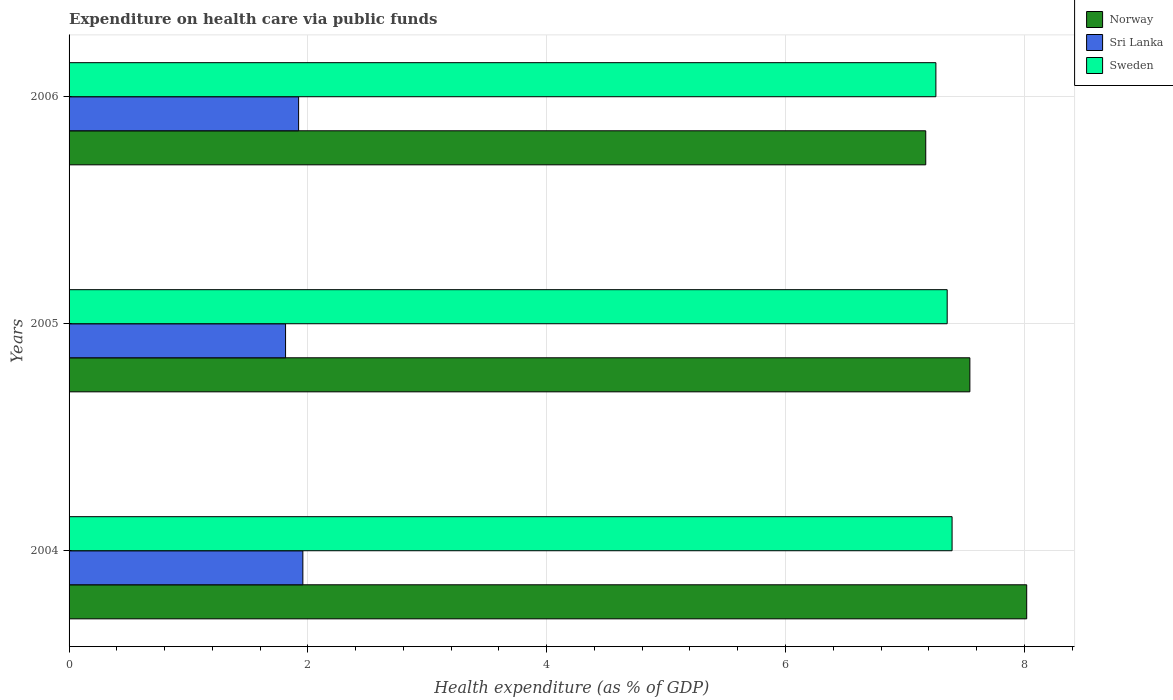Are the number of bars per tick equal to the number of legend labels?
Provide a short and direct response. Yes. Are the number of bars on each tick of the Y-axis equal?
Your answer should be very brief. Yes. How many bars are there on the 1st tick from the top?
Offer a terse response. 3. What is the expenditure made on health care in Sri Lanka in 2006?
Make the answer very short. 1.92. Across all years, what is the maximum expenditure made on health care in Sri Lanka?
Offer a terse response. 1.96. Across all years, what is the minimum expenditure made on health care in Norway?
Your response must be concise. 7.17. In which year was the expenditure made on health care in Sri Lanka maximum?
Offer a very short reply. 2004. In which year was the expenditure made on health care in Norway minimum?
Ensure brevity in your answer.  2006. What is the total expenditure made on health care in Norway in the graph?
Provide a short and direct response. 22.74. What is the difference between the expenditure made on health care in Norway in 2005 and that in 2006?
Your answer should be compact. 0.37. What is the difference between the expenditure made on health care in Sweden in 2006 and the expenditure made on health care in Norway in 2005?
Make the answer very short. -0.28. What is the average expenditure made on health care in Sweden per year?
Offer a terse response. 7.34. In the year 2004, what is the difference between the expenditure made on health care in Sweden and expenditure made on health care in Norway?
Give a very brief answer. -0.62. In how many years, is the expenditure made on health care in Norway greater than 7.2 %?
Offer a very short reply. 2. What is the ratio of the expenditure made on health care in Sweden in 2004 to that in 2005?
Provide a succinct answer. 1.01. Is the expenditure made on health care in Sri Lanka in 2005 less than that in 2006?
Your answer should be compact. Yes. What is the difference between the highest and the second highest expenditure made on health care in Sweden?
Provide a succinct answer. 0.04. What is the difference between the highest and the lowest expenditure made on health care in Sri Lanka?
Keep it short and to the point. 0.14. In how many years, is the expenditure made on health care in Norway greater than the average expenditure made on health care in Norway taken over all years?
Your response must be concise. 1. What does the 2nd bar from the top in 2004 represents?
Provide a succinct answer. Sri Lanka. What does the 3rd bar from the bottom in 2004 represents?
Offer a very short reply. Sweden. How many bars are there?
Make the answer very short. 9. How many years are there in the graph?
Give a very brief answer. 3. Does the graph contain any zero values?
Your response must be concise. No. Does the graph contain grids?
Your answer should be very brief. Yes. Where does the legend appear in the graph?
Provide a succinct answer. Top right. What is the title of the graph?
Make the answer very short. Expenditure on health care via public funds. What is the label or title of the X-axis?
Keep it short and to the point. Health expenditure (as % of GDP). What is the label or title of the Y-axis?
Your response must be concise. Years. What is the Health expenditure (as % of GDP) of Norway in 2004?
Ensure brevity in your answer.  8.02. What is the Health expenditure (as % of GDP) in Sri Lanka in 2004?
Your response must be concise. 1.96. What is the Health expenditure (as % of GDP) of Sweden in 2004?
Keep it short and to the point. 7.4. What is the Health expenditure (as % of GDP) of Norway in 2005?
Give a very brief answer. 7.54. What is the Health expenditure (as % of GDP) of Sri Lanka in 2005?
Provide a succinct answer. 1.81. What is the Health expenditure (as % of GDP) of Sweden in 2005?
Your answer should be compact. 7.35. What is the Health expenditure (as % of GDP) in Norway in 2006?
Your answer should be compact. 7.17. What is the Health expenditure (as % of GDP) in Sri Lanka in 2006?
Offer a terse response. 1.92. What is the Health expenditure (as % of GDP) in Sweden in 2006?
Keep it short and to the point. 7.26. Across all years, what is the maximum Health expenditure (as % of GDP) in Norway?
Provide a short and direct response. 8.02. Across all years, what is the maximum Health expenditure (as % of GDP) in Sri Lanka?
Offer a very short reply. 1.96. Across all years, what is the maximum Health expenditure (as % of GDP) of Sweden?
Offer a terse response. 7.4. Across all years, what is the minimum Health expenditure (as % of GDP) in Norway?
Offer a very short reply. 7.17. Across all years, what is the minimum Health expenditure (as % of GDP) of Sri Lanka?
Ensure brevity in your answer.  1.81. Across all years, what is the minimum Health expenditure (as % of GDP) of Sweden?
Provide a succinct answer. 7.26. What is the total Health expenditure (as % of GDP) of Norway in the graph?
Your answer should be very brief. 22.74. What is the total Health expenditure (as % of GDP) in Sri Lanka in the graph?
Provide a succinct answer. 5.69. What is the total Health expenditure (as % of GDP) in Sweden in the graph?
Your answer should be very brief. 22.01. What is the difference between the Health expenditure (as % of GDP) of Norway in 2004 and that in 2005?
Give a very brief answer. 0.48. What is the difference between the Health expenditure (as % of GDP) of Sri Lanka in 2004 and that in 2005?
Your response must be concise. 0.14. What is the difference between the Health expenditure (as % of GDP) in Sweden in 2004 and that in 2005?
Make the answer very short. 0.04. What is the difference between the Health expenditure (as % of GDP) of Norway in 2004 and that in 2006?
Your answer should be very brief. 0.85. What is the difference between the Health expenditure (as % of GDP) in Sri Lanka in 2004 and that in 2006?
Keep it short and to the point. 0.04. What is the difference between the Health expenditure (as % of GDP) of Sweden in 2004 and that in 2006?
Provide a succinct answer. 0.14. What is the difference between the Health expenditure (as % of GDP) of Norway in 2005 and that in 2006?
Offer a very short reply. 0.37. What is the difference between the Health expenditure (as % of GDP) in Sri Lanka in 2005 and that in 2006?
Your response must be concise. -0.11. What is the difference between the Health expenditure (as % of GDP) of Sweden in 2005 and that in 2006?
Offer a terse response. 0.09. What is the difference between the Health expenditure (as % of GDP) in Norway in 2004 and the Health expenditure (as % of GDP) in Sri Lanka in 2005?
Provide a short and direct response. 6.21. What is the difference between the Health expenditure (as % of GDP) of Norway in 2004 and the Health expenditure (as % of GDP) of Sweden in 2005?
Provide a succinct answer. 0.67. What is the difference between the Health expenditure (as % of GDP) in Sri Lanka in 2004 and the Health expenditure (as % of GDP) in Sweden in 2005?
Keep it short and to the point. -5.4. What is the difference between the Health expenditure (as % of GDP) in Norway in 2004 and the Health expenditure (as % of GDP) in Sri Lanka in 2006?
Give a very brief answer. 6.1. What is the difference between the Health expenditure (as % of GDP) in Norway in 2004 and the Health expenditure (as % of GDP) in Sweden in 2006?
Ensure brevity in your answer.  0.76. What is the difference between the Health expenditure (as % of GDP) of Sri Lanka in 2004 and the Health expenditure (as % of GDP) of Sweden in 2006?
Offer a terse response. -5.3. What is the difference between the Health expenditure (as % of GDP) of Norway in 2005 and the Health expenditure (as % of GDP) of Sri Lanka in 2006?
Make the answer very short. 5.62. What is the difference between the Health expenditure (as % of GDP) of Norway in 2005 and the Health expenditure (as % of GDP) of Sweden in 2006?
Provide a succinct answer. 0.28. What is the difference between the Health expenditure (as % of GDP) of Sri Lanka in 2005 and the Health expenditure (as % of GDP) of Sweden in 2006?
Your answer should be very brief. -5.45. What is the average Health expenditure (as % of GDP) of Norway per year?
Give a very brief answer. 7.58. What is the average Health expenditure (as % of GDP) of Sri Lanka per year?
Offer a terse response. 1.9. What is the average Health expenditure (as % of GDP) of Sweden per year?
Offer a very short reply. 7.34. In the year 2004, what is the difference between the Health expenditure (as % of GDP) of Norway and Health expenditure (as % of GDP) of Sri Lanka?
Make the answer very short. 6.06. In the year 2004, what is the difference between the Health expenditure (as % of GDP) in Norway and Health expenditure (as % of GDP) in Sweden?
Offer a very short reply. 0.62. In the year 2004, what is the difference between the Health expenditure (as % of GDP) of Sri Lanka and Health expenditure (as % of GDP) of Sweden?
Your answer should be very brief. -5.44. In the year 2005, what is the difference between the Health expenditure (as % of GDP) of Norway and Health expenditure (as % of GDP) of Sri Lanka?
Offer a terse response. 5.73. In the year 2005, what is the difference between the Health expenditure (as % of GDP) in Norway and Health expenditure (as % of GDP) in Sweden?
Make the answer very short. 0.19. In the year 2005, what is the difference between the Health expenditure (as % of GDP) of Sri Lanka and Health expenditure (as % of GDP) of Sweden?
Your answer should be very brief. -5.54. In the year 2006, what is the difference between the Health expenditure (as % of GDP) of Norway and Health expenditure (as % of GDP) of Sri Lanka?
Provide a succinct answer. 5.25. In the year 2006, what is the difference between the Health expenditure (as % of GDP) in Norway and Health expenditure (as % of GDP) in Sweden?
Make the answer very short. -0.08. In the year 2006, what is the difference between the Health expenditure (as % of GDP) in Sri Lanka and Health expenditure (as % of GDP) in Sweden?
Your answer should be very brief. -5.34. What is the ratio of the Health expenditure (as % of GDP) of Norway in 2004 to that in 2005?
Provide a short and direct response. 1.06. What is the ratio of the Health expenditure (as % of GDP) in Sri Lanka in 2004 to that in 2005?
Your answer should be very brief. 1.08. What is the ratio of the Health expenditure (as % of GDP) in Sweden in 2004 to that in 2005?
Make the answer very short. 1.01. What is the ratio of the Health expenditure (as % of GDP) in Norway in 2004 to that in 2006?
Your response must be concise. 1.12. What is the ratio of the Health expenditure (as % of GDP) of Sri Lanka in 2004 to that in 2006?
Ensure brevity in your answer.  1.02. What is the ratio of the Health expenditure (as % of GDP) in Sweden in 2004 to that in 2006?
Provide a succinct answer. 1.02. What is the ratio of the Health expenditure (as % of GDP) of Norway in 2005 to that in 2006?
Your answer should be very brief. 1.05. What is the ratio of the Health expenditure (as % of GDP) of Sri Lanka in 2005 to that in 2006?
Make the answer very short. 0.94. What is the difference between the highest and the second highest Health expenditure (as % of GDP) in Norway?
Provide a short and direct response. 0.48. What is the difference between the highest and the second highest Health expenditure (as % of GDP) in Sri Lanka?
Offer a terse response. 0.04. What is the difference between the highest and the second highest Health expenditure (as % of GDP) in Sweden?
Offer a terse response. 0.04. What is the difference between the highest and the lowest Health expenditure (as % of GDP) of Norway?
Provide a short and direct response. 0.85. What is the difference between the highest and the lowest Health expenditure (as % of GDP) of Sri Lanka?
Provide a succinct answer. 0.14. What is the difference between the highest and the lowest Health expenditure (as % of GDP) in Sweden?
Offer a very short reply. 0.14. 